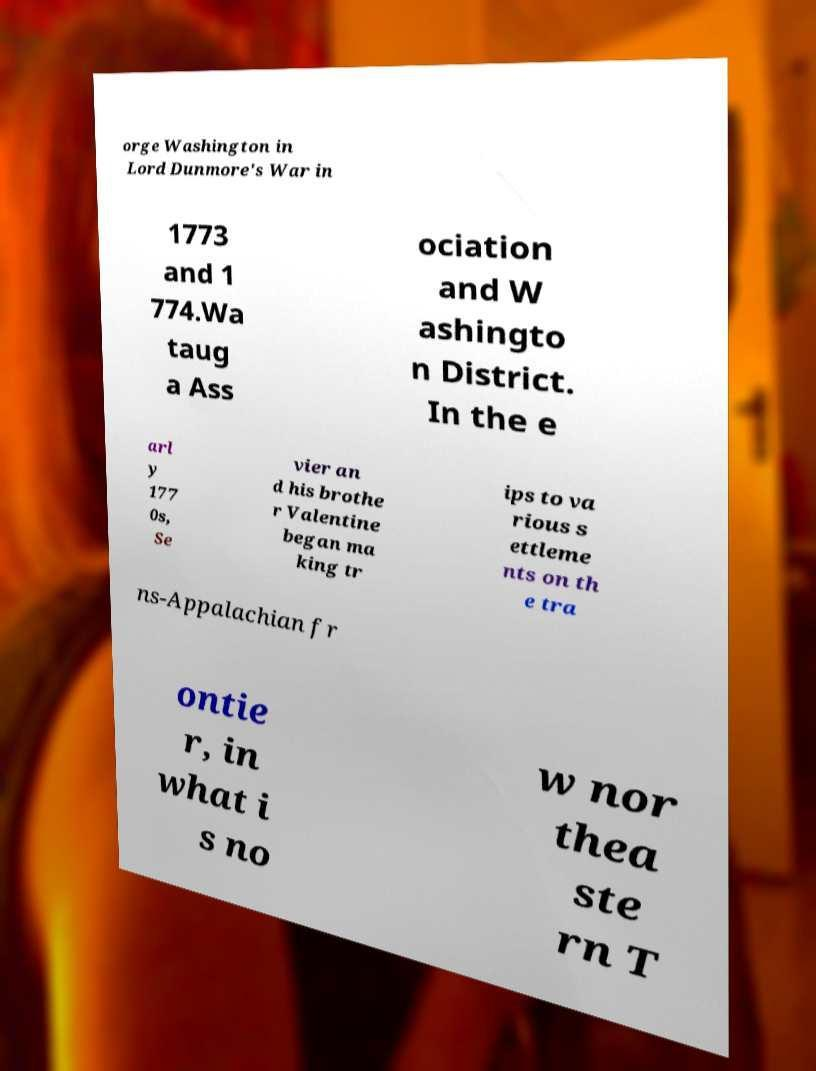Can you accurately transcribe the text from the provided image for me? orge Washington in Lord Dunmore's War in 1773 and 1 774.Wa taug a Ass ociation and W ashingto n District. In the e arl y 177 0s, Se vier an d his brothe r Valentine began ma king tr ips to va rious s ettleme nts on th e tra ns-Appalachian fr ontie r, in what i s no w nor thea ste rn T 